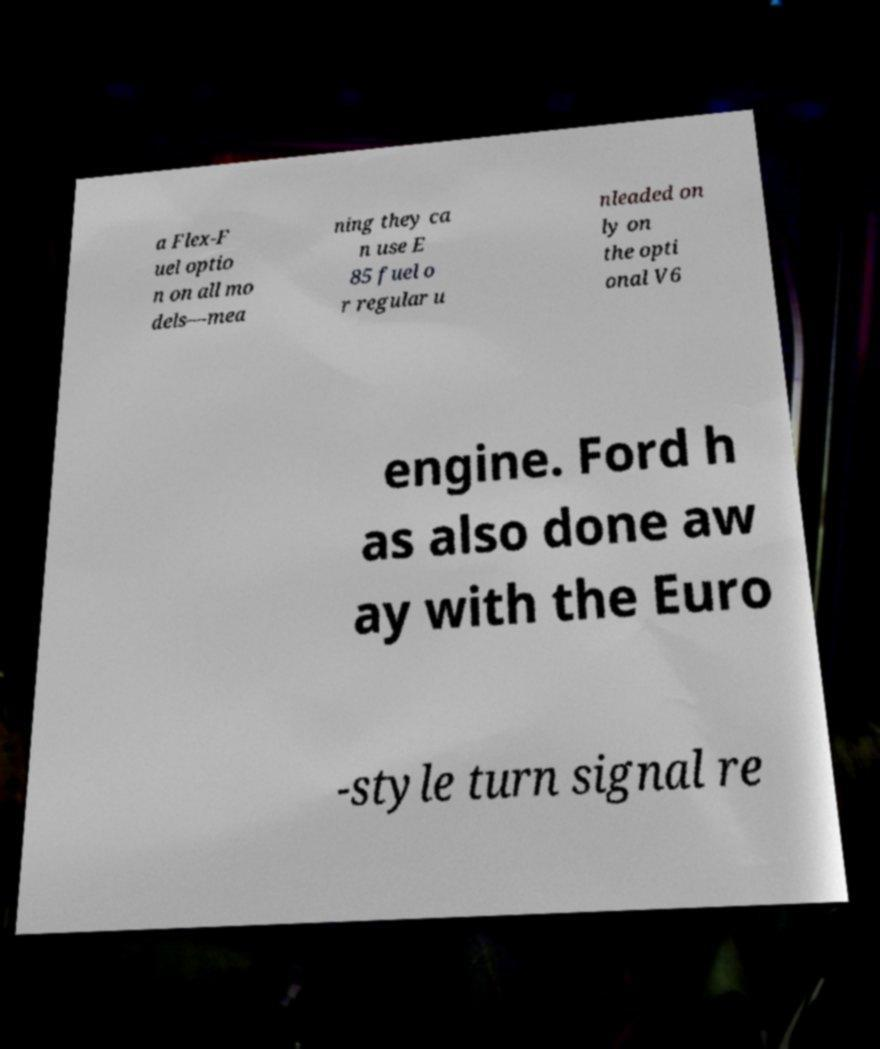What messages or text are displayed in this image? I need them in a readable, typed format. a Flex-F uel optio n on all mo dels—mea ning they ca n use E 85 fuel o r regular u nleaded on ly on the opti onal V6 engine. Ford h as also done aw ay with the Euro -style turn signal re 